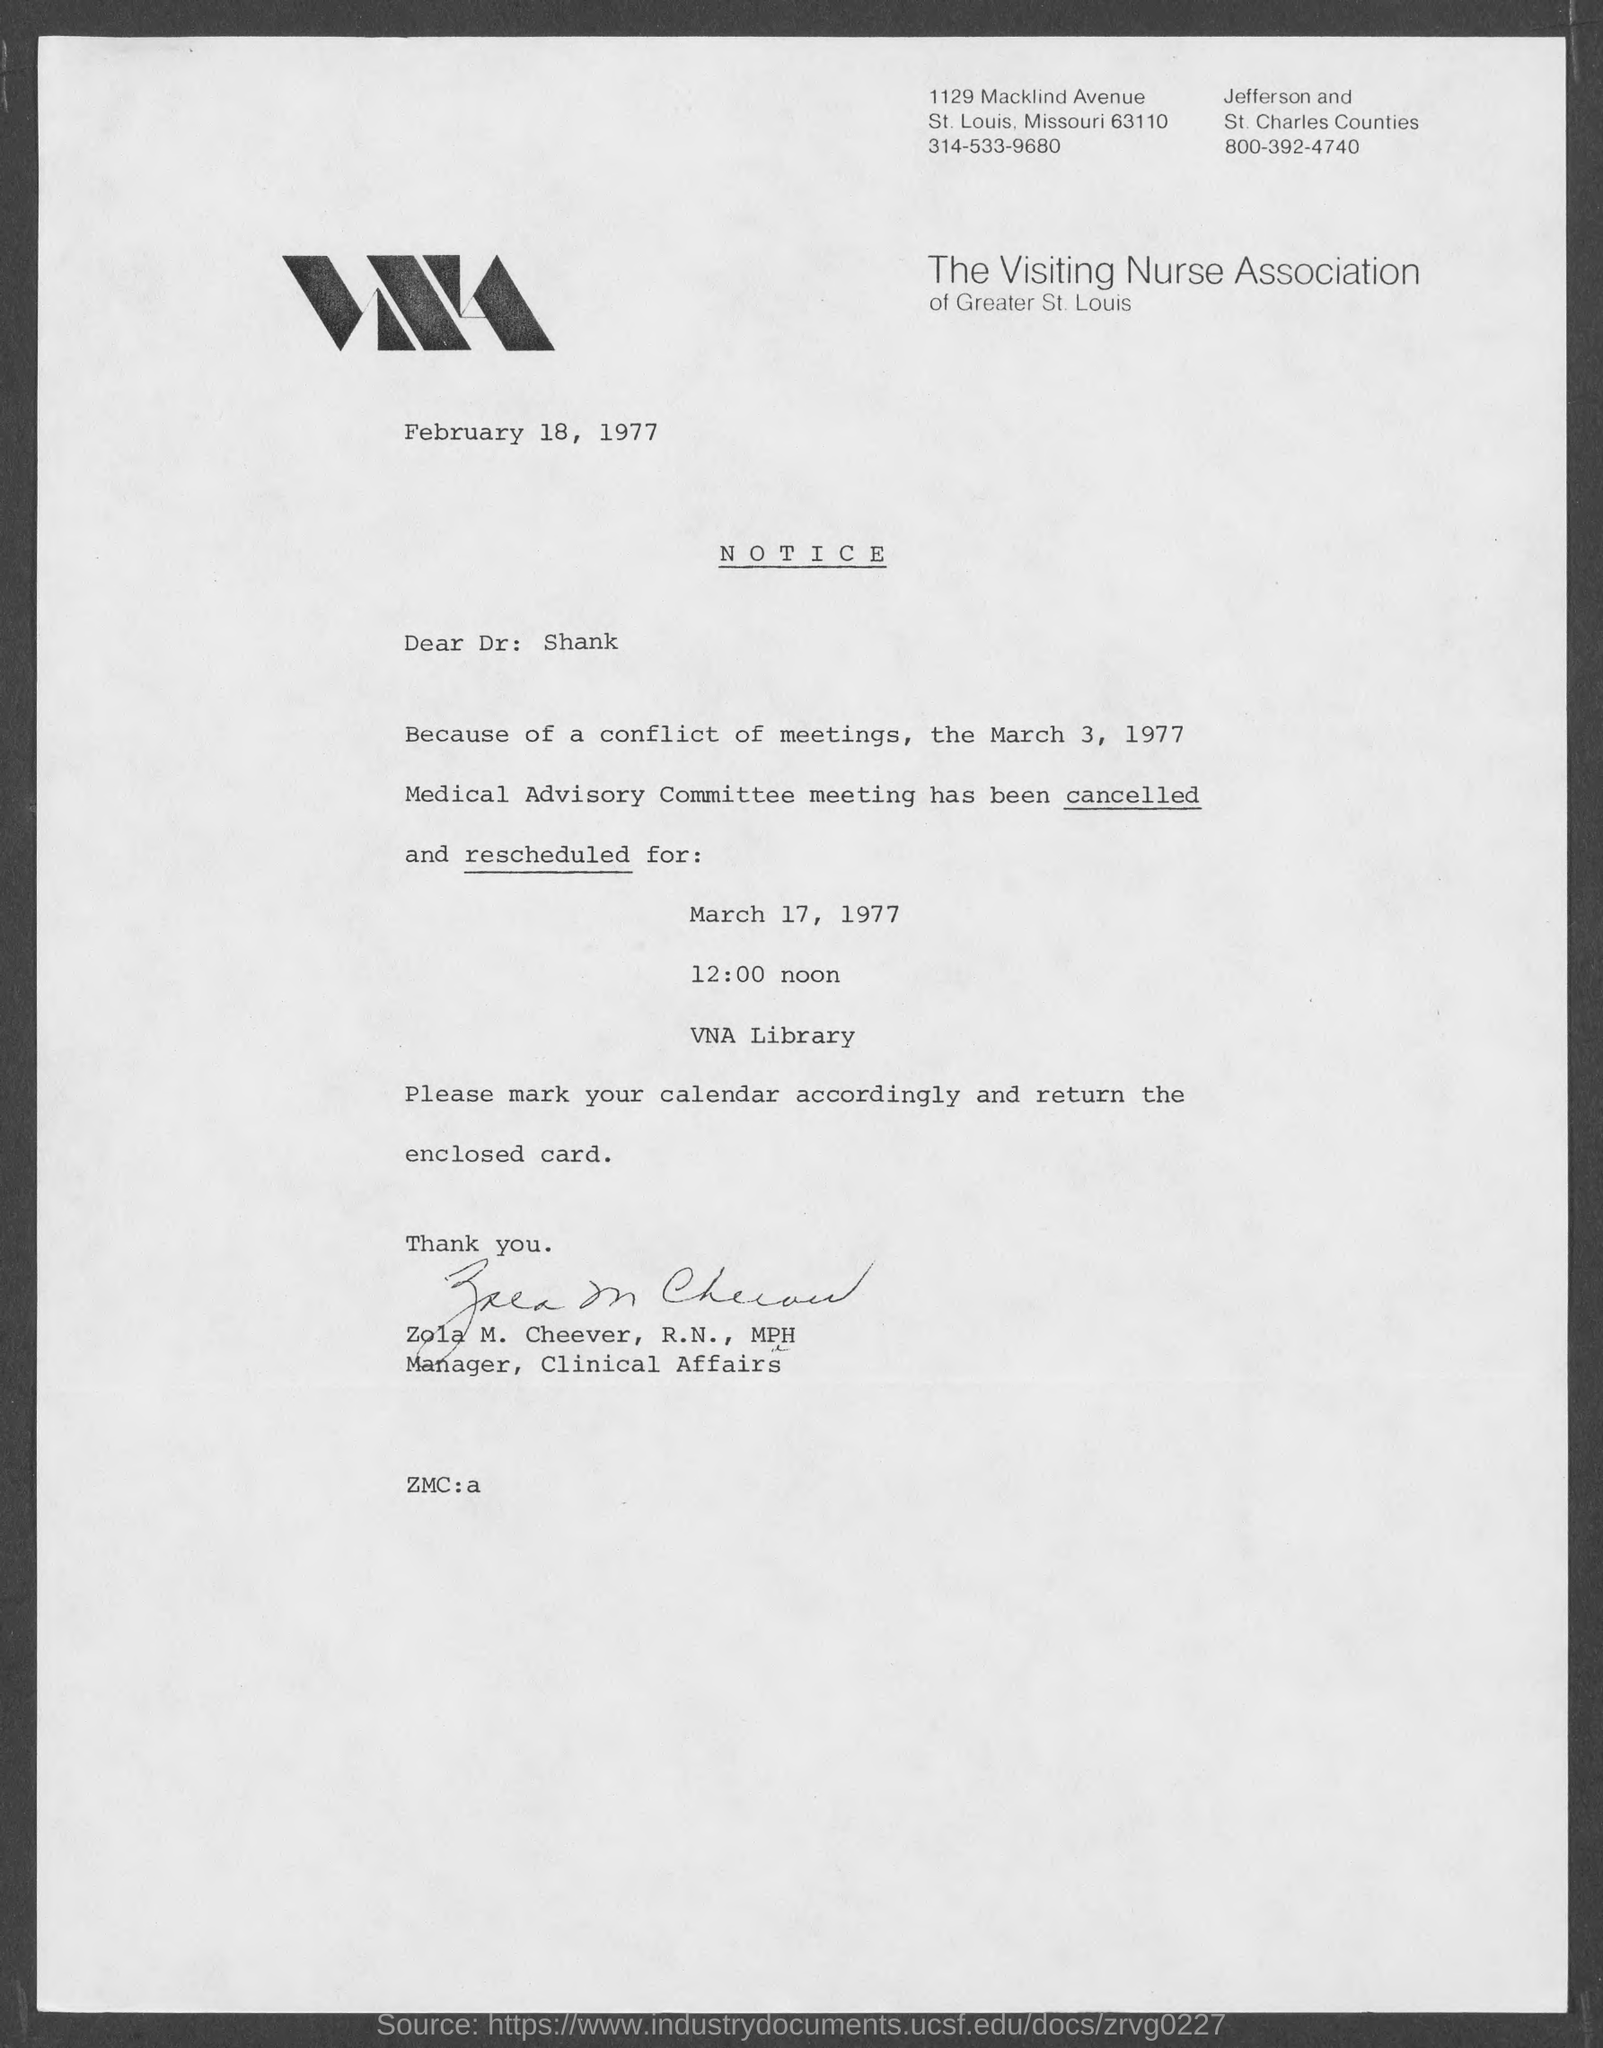Indicate a few pertinent items in this graphic. The memorandum is from Zola M. Cheever, R.N., MPH. The date mentioned at the top of the document is February 18, 1977. 